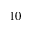<formula> <loc_0><loc_0><loc_500><loc_500>1 0</formula> 